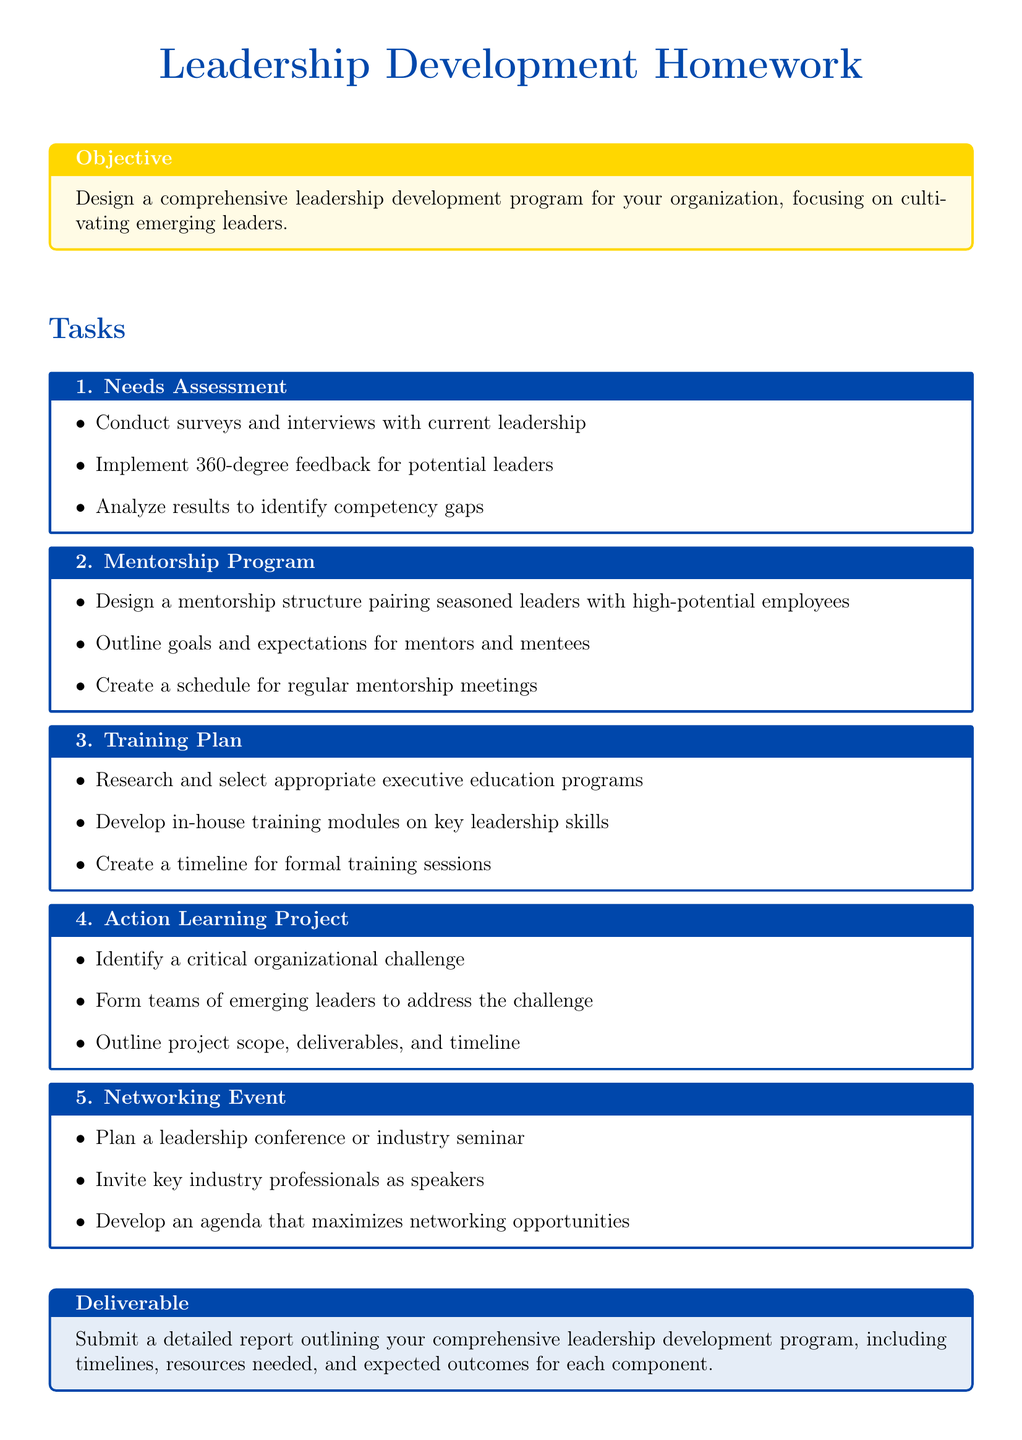What is the title of the document? The title of the document is indicated at the top of the rendered output, stating its focus on leadership development homework.
Answer: Leadership Development Homework What is the main color used in the document? The main color is used throughout the document for text and frames, and it's defined at the beginning.
Answer: RGB(0,71,171) How many tasks are outlined in the document? The document includes a total of five distinct tasks for developing leadership.
Answer: 5 What is the purpose of the mentorship program task? The mentorship program task focuses on pairing seasoned leaders with high-potential employees for developing leadership skills.
Answer: Pairing seasoned leaders with high-potential employees What is required in the deliverable section? The deliverable section specifies that a detailed report outlining the leadership development program is to be submitted.
Answer: Detailed report What kind of feedback method is mentioned in the needs assessment task? The needs assessment mentions implementing a specific feedback method for evaluating potential leaders.
Answer: 360-degree feedback What is a key component of the training plan task? The training plan task involves researching and selecting appropriate programs for enhancing leadership skills.
Answer: Executive education programs What should be identified in the action learning project task? The action learning project task requires identifying a specific challenge within the organization for team focus.
Answer: Critical organizational challenge What type of event is suggested in the networking event task? The networking event task suggests planning a specific type of professional gathering to encourage industry connections.
Answer: Leadership conference 